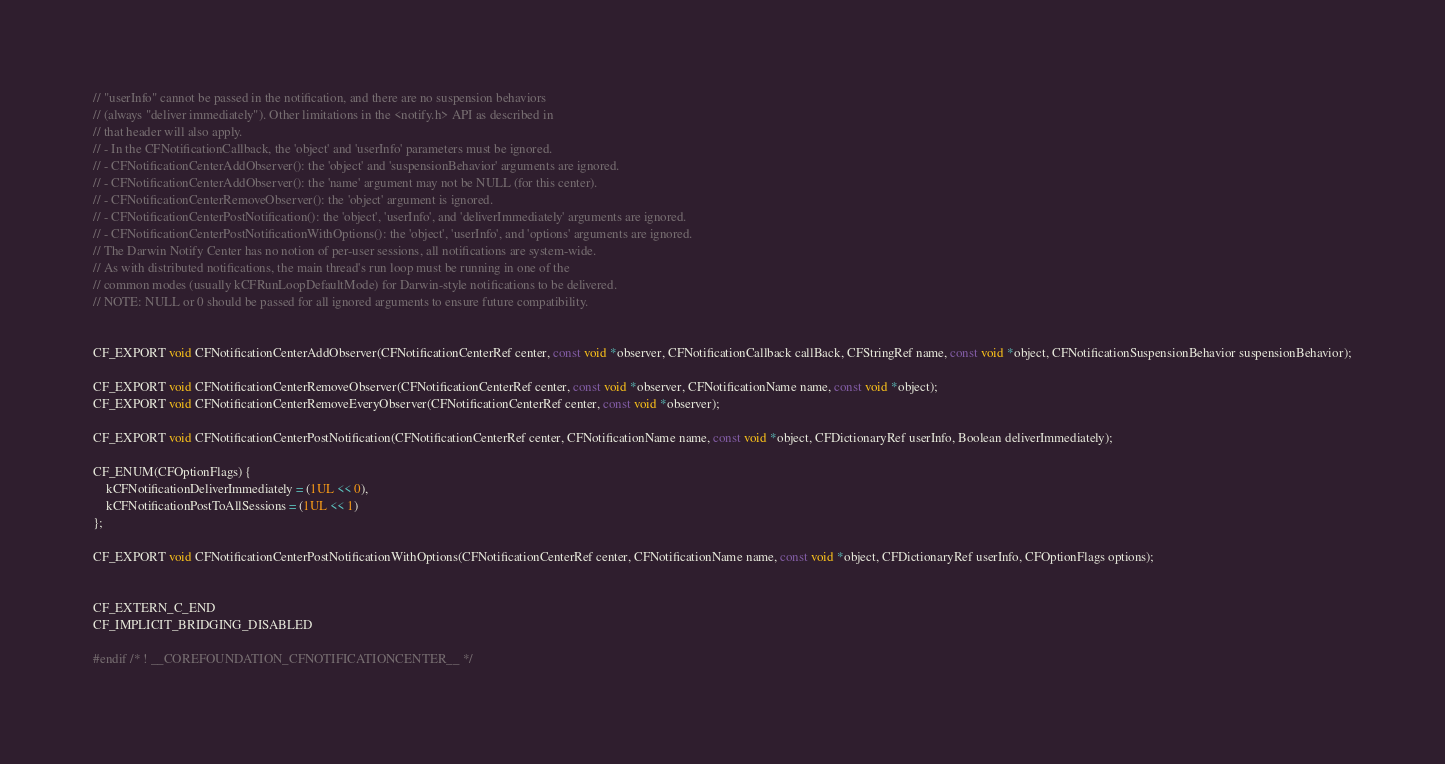Convert code to text. <code><loc_0><loc_0><loc_500><loc_500><_C_>// "userInfo" cannot be passed in the notification, and there are no suspension behaviors
// (always "deliver immediately"). Other limitations in the <notify.h> API as described in
// that header will also apply.
// - In the CFNotificationCallback, the 'object' and 'userInfo' parameters must be ignored.
// - CFNotificationCenterAddObserver(): the 'object' and 'suspensionBehavior' arguments are ignored.
// - CFNotificationCenterAddObserver(): the 'name' argument may not be NULL (for this center).
// - CFNotificationCenterRemoveObserver(): the 'object' argument is ignored.
// - CFNotificationCenterPostNotification(): the 'object', 'userInfo', and 'deliverImmediately' arguments are ignored.
// - CFNotificationCenterPostNotificationWithOptions(): the 'object', 'userInfo', and 'options' arguments are ignored.
// The Darwin Notify Center has no notion of per-user sessions, all notifications are system-wide.
// As with distributed notifications, the main thread's run loop must be running in one of the
// common modes (usually kCFRunLoopDefaultMode) for Darwin-style notifications to be delivered.
// NOTE: NULL or 0 should be passed for all ignored arguments to ensure future compatibility.


CF_EXPORT void CFNotificationCenterAddObserver(CFNotificationCenterRef center, const void *observer, CFNotificationCallback callBack, CFStringRef name, const void *object, CFNotificationSuspensionBehavior suspensionBehavior);

CF_EXPORT void CFNotificationCenterRemoveObserver(CFNotificationCenterRef center, const void *observer, CFNotificationName name, const void *object);
CF_EXPORT void CFNotificationCenterRemoveEveryObserver(CFNotificationCenterRef center, const void *observer);

CF_EXPORT void CFNotificationCenterPostNotification(CFNotificationCenterRef center, CFNotificationName name, const void *object, CFDictionaryRef userInfo, Boolean deliverImmediately);

CF_ENUM(CFOptionFlags) {
    kCFNotificationDeliverImmediately = (1UL << 0),
    kCFNotificationPostToAllSessions = (1UL << 1)
};

CF_EXPORT void CFNotificationCenterPostNotificationWithOptions(CFNotificationCenterRef center, CFNotificationName name, const void *object, CFDictionaryRef userInfo, CFOptionFlags options);


CF_EXTERN_C_END
CF_IMPLICIT_BRIDGING_DISABLED

#endif /* ! __COREFOUNDATION_CFNOTIFICATIONCENTER__ */

</code> 